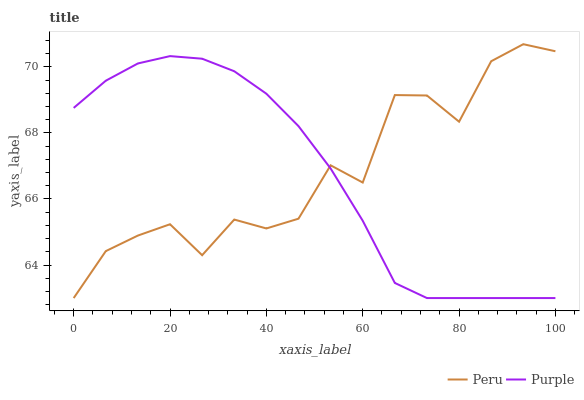Does Purple have the minimum area under the curve?
Answer yes or no. Yes. Does Peru have the maximum area under the curve?
Answer yes or no. Yes. Does Peru have the minimum area under the curve?
Answer yes or no. No. Is Purple the smoothest?
Answer yes or no. Yes. Is Peru the roughest?
Answer yes or no. Yes. Is Peru the smoothest?
Answer yes or no. No. Does Purple have the lowest value?
Answer yes or no. Yes. Does Peru have the highest value?
Answer yes or no. Yes. Does Peru intersect Purple?
Answer yes or no. Yes. Is Peru less than Purple?
Answer yes or no. No. Is Peru greater than Purple?
Answer yes or no. No. 